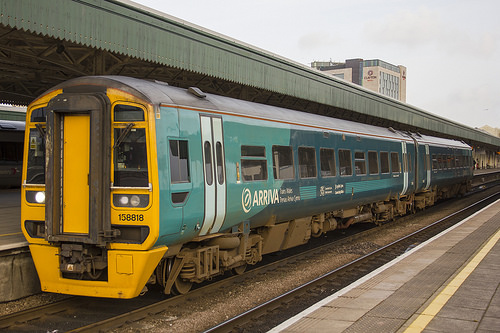<image>
Is there a train on the train station? No. The train is not positioned on the train station. They may be near each other, but the train is not supported by or resting on top of the train station. 